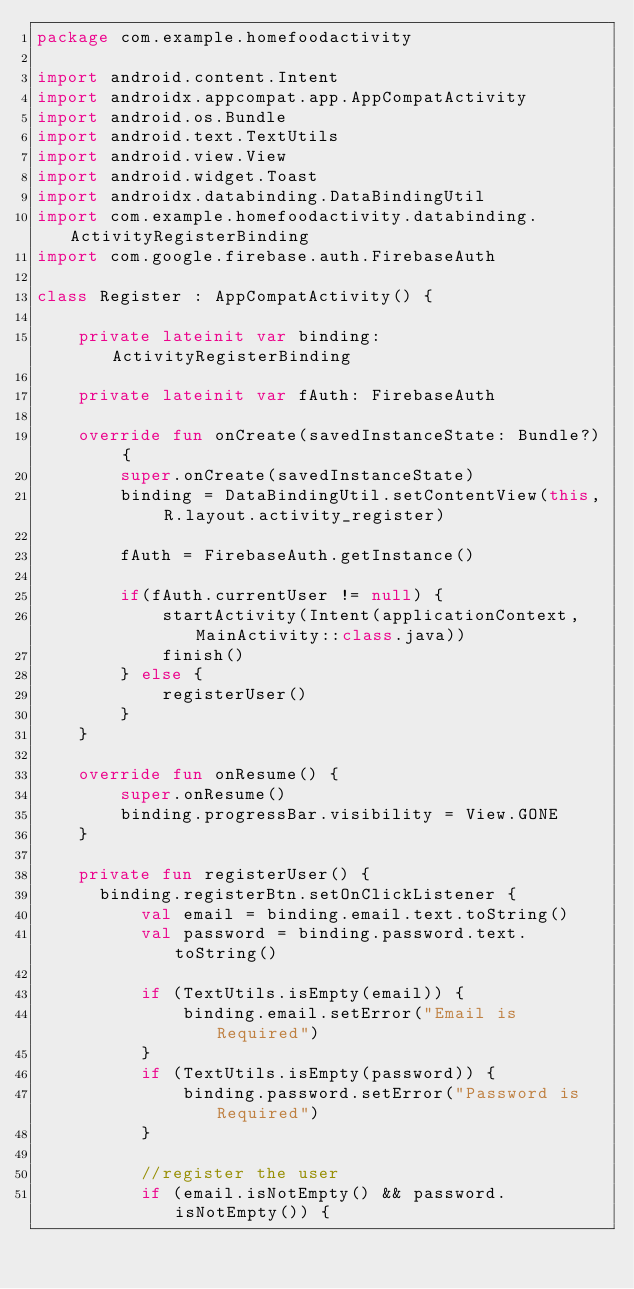Convert code to text. <code><loc_0><loc_0><loc_500><loc_500><_Kotlin_>package com.example.homefoodactivity

import android.content.Intent
import androidx.appcompat.app.AppCompatActivity
import android.os.Bundle
import android.text.TextUtils
import android.view.View
import android.widget.Toast
import androidx.databinding.DataBindingUtil
import com.example.homefoodactivity.databinding.ActivityRegisterBinding
import com.google.firebase.auth.FirebaseAuth

class Register : AppCompatActivity() {

    private lateinit var binding: ActivityRegisterBinding

    private lateinit var fAuth: FirebaseAuth

    override fun onCreate(savedInstanceState: Bundle?) {
        super.onCreate(savedInstanceState)
        binding = DataBindingUtil.setContentView(this, R.layout.activity_register)

        fAuth = FirebaseAuth.getInstance()

        if(fAuth.currentUser != null) {
            startActivity(Intent(applicationContext, MainActivity::class.java))
            finish()
        } else {
            registerUser()
        }
    }

    override fun onResume() {
        super.onResume()
        binding.progressBar.visibility = View.GONE
    }

    private fun registerUser() {
      binding.registerBtn.setOnClickListener {
          val email = binding.email.text.toString()
          val password = binding.password.text.toString()

          if (TextUtils.isEmpty(email)) {
              binding.email.setError("Email is Required")
          }
          if (TextUtils.isEmpty(password)) {
              binding.password.setError("Password is Required")
          }

          //register the user
          if (email.isNotEmpty() && password.isNotEmpty()) {</code> 